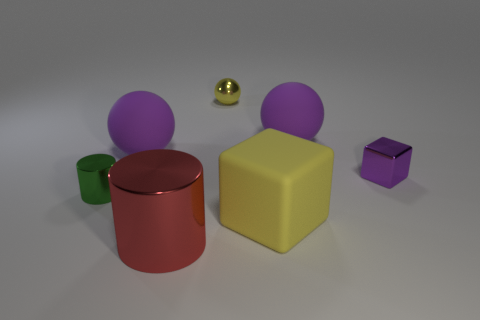Does the image represent a real-life scene? The image appears to be a computer-generated render as evidenced by the uniform lighting, perfect geometric shapes, and absence of context typically surrounding such objects in a real-world setting. 